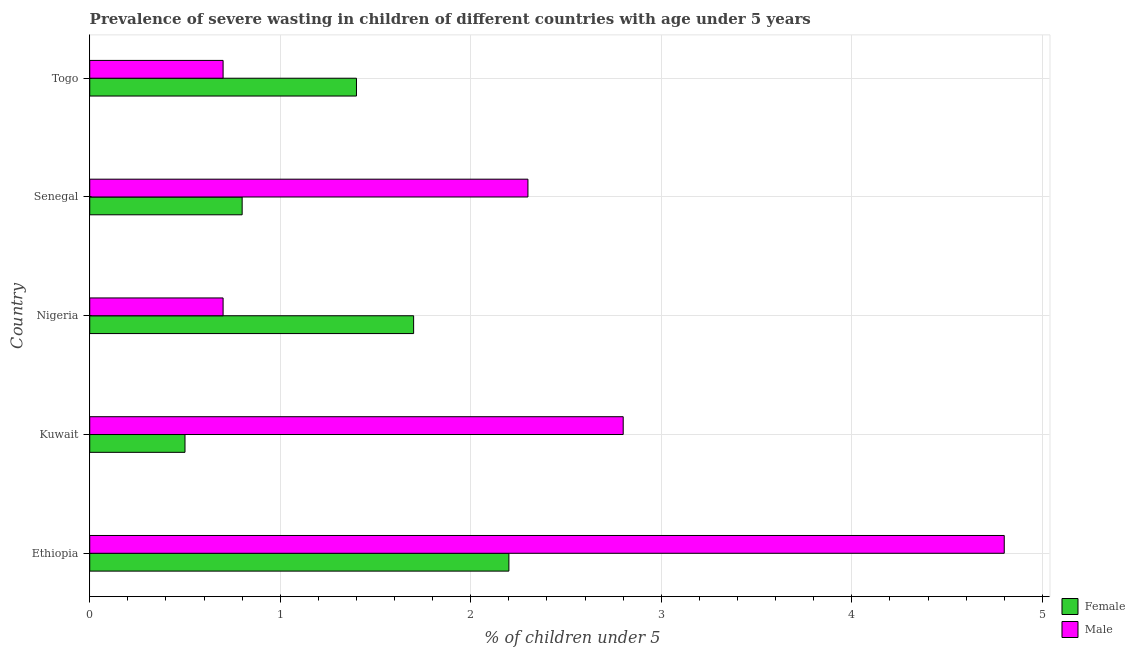How many groups of bars are there?
Provide a short and direct response. 5. Are the number of bars on each tick of the Y-axis equal?
Keep it short and to the point. Yes. How many bars are there on the 2nd tick from the bottom?
Make the answer very short. 2. What is the label of the 1st group of bars from the top?
Keep it short and to the point. Togo. In how many cases, is the number of bars for a given country not equal to the number of legend labels?
Your response must be concise. 0. What is the percentage of undernourished male children in Ethiopia?
Make the answer very short. 4.8. Across all countries, what is the maximum percentage of undernourished female children?
Ensure brevity in your answer.  2.2. Across all countries, what is the minimum percentage of undernourished male children?
Offer a very short reply. 0.7. In which country was the percentage of undernourished female children maximum?
Make the answer very short. Ethiopia. In which country was the percentage of undernourished male children minimum?
Keep it short and to the point. Nigeria. What is the total percentage of undernourished male children in the graph?
Your response must be concise. 11.3. What is the difference between the percentage of undernourished male children in Nigeria and the percentage of undernourished female children in Senegal?
Keep it short and to the point. -0.1. What is the average percentage of undernourished female children per country?
Your answer should be very brief. 1.32. What is the difference between the percentage of undernourished male children and percentage of undernourished female children in Kuwait?
Your response must be concise. 2.3. In how many countries, is the percentage of undernourished male children greater than 1.8 %?
Your answer should be compact. 3. What is the ratio of the percentage of undernourished female children in Nigeria to that in Senegal?
Provide a short and direct response. 2.12. In how many countries, is the percentage of undernourished female children greater than the average percentage of undernourished female children taken over all countries?
Keep it short and to the point. 3. Is the sum of the percentage of undernourished male children in Nigeria and Togo greater than the maximum percentage of undernourished female children across all countries?
Your answer should be compact. No. What does the 2nd bar from the top in Togo represents?
Keep it short and to the point. Female. How many countries are there in the graph?
Make the answer very short. 5. Does the graph contain any zero values?
Give a very brief answer. No. How are the legend labels stacked?
Give a very brief answer. Vertical. What is the title of the graph?
Provide a short and direct response. Prevalence of severe wasting in children of different countries with age under 5 years. What is the label or title of the X-axis?
Your answer should be compact.  % of children under 5. What is the  % of children under 5 in Female in Ethiopia?
Keep it short and to the point. 2.2. What is the  % of children under 5 in Male in Ethiopia?
Your response must be concise. 4.8. What is the  % of children under 5 in Female in Kuwait?
Your answer should be very brief. 0.5. What is the  % of children under 5 of Male in Kuwait?
Your answer should be very brief. 2.8. What is the  % of children under 5 of Female in Nigeria?
Provide a succinct answer. 1.7. What is the  % of children under 5 in Male in Nigeria?
Keep it short and to the point. 0.7. What is the  % of children under 5 of Female in Senegal?
Make the answer very short. 0.8. What is the  % of children under 5 of Male in Senegal?
Offer a very short reply. 2.3. What is the  % of children under 5 in Female in Togo?
Ensure brevity in your answer.  1.4. What is the  % of children under 5 in Male in Togo?
Your answer should be compact. 0.7. Across all countries, what is the maximum  % of children under 5 of Female?
Offer a terse response. 2.2. Across all countries, what is the maximum  % of children under 5 in Male?
Provide a succinct answer. 4.8. Across all countries, what is the minimum  % of children under 5 in Male?
Ensure brevity in your answer.  0.7. What is the total  % of children under 5 of Female in the graph?
Provide a succinct answer. 6.6. What is the difference between the  % of children under 5 in Female in Ethiopia and that in Kuwait?
Provide a succinct answer. 1.7. What is the difference between the  % of children under 5 in Female in Ethiopia and that in Nigeria?
Ensure brevity in your answer.  0.5. What is the difference between the  % of children under 5 of Male in Ethiopia and that in Nigeria?
Provide a short and direct response. 4.1. What is the difference between the  % of children under 5 in Male in Ethiopia and that in Senegal?
Make the answer very short. 2.5. What is the difference between the  % of children under 5 of Male in Ethiopia and that in Togo?
Your answer should be compact. 4.1. What is the difference between the  % of children under 5 in Female in Kuwait and that in Nigeria?
Offer a terse response. -1.2. What is the difference between the  % of children under 5 in Female in Kuwait and that in Senegal?
Provide a succinct answer. -0.3. What is the difference between the  % of children under 5 of Male in Kuwait and that in Senegal?
Provide a succinct answer. 0.5. What is the difference between the  % of children under 5 of Female in Kuwait and that in Togo?
Offer a very short reply. -0.9. What is the difference between the  % of children under 5 in Female in Senegal and that in Togo?
Your answer should be compact. -0.6. What is the difference between the  % of children under 5 of Male in Senegal and that in Togo?
Your answer should be very brief. 1.6. What is the difference between the  % of children under 5 in Female in Ethiopia and the  % of children under 5 in Male in Kuwait?
Make the answer very short. -0.6. What is the difference between the  % of children under 5 in Female in Ethiopia and the  % of children under 5 in Male in Nigeria?
Offer a very short reply. 1.5. What is the difference between the  % of children under 5 of Female in Kuwait and the  % of children under 5 of Male in Nigeria?
Your response must be concise. -0.2. What is the difference between the  % of children under 5 in Female in Kuwait and the  % of children under 5 in Male in Senegal?
Keep it short and to the point. -1.8. What is the difference between the  % of children under 5 in Female in Kuwait and the  % of children under 5 in Male in Togo?
Your response must be concise. -0.2. What is the difference between the  % of children under 5 of Female in Nigeria and the  % of children under 5 of Male in Senegal?
Your answer should be compact. -0.6. What is the difference between the  % of children under 5 of Female in Nigeria and the  % of children under 5 of Male in Togo?
Your answer should be compact. 1. What is the difference between the  % of children under 5 of Female in Senegal and the  % of children under 5 of Male in Togo?
Your answer should be very brief. 0.1. What is the average  % of children under 5 in Female per country?
Your response must be concise. 1.32. What is the average  % of children under 5 of Male per country?
Give a very brief answer. 2.26. What is the difference between the  % of children under 5 of Female and  % of children under 5 of Male in Kuwait?
Offer a very short reply. -2.3. What is the difference between the  % of children under 5 of Female and  % of children under 5 of Male in Togo?
Offer a very short reply. 0.7. What is the ratio of the  % of children under 5 in Female in Ethiopia to that in Kuwait?
Give a very brief answer. 4.4. What is the ratio of the  % of children under 5 in Male in Ethiopia to that in Kuwait?
Offer a terse response. 1.71. What is the ratio of the  % of children under 5 of Female in Ethiopia to that in Nigeria?
Offer a very short reply. 1.29. What is the ratio of the  % of children under 5 in Male in Ethiopia to that in Nigeria?
Offer a terse response. 6.86. What is the ratio of the  % of children under 5 of Female in Ethiopia to that in Senegal?
Make the answer very short. 2.75. What is the ratio of the  % of children under 5 in Male in Ethiopia to that in Senegal?
Offer a terse response. 2.09. What is the ratio of the  % of children under 5 of Female in Ethiopia to that in Togo?
Give a very brief answer. 1.57. What is the ratio of the  % of children under 5 of Male in Ethiopia to that in Togo?
Your answer should be compact. 6.86. What is the ratio of the  % of children under 5 of Female in Kuwait to that in Nigeria?
Provide a succinct answer. 0.29. What is the ratio of the  % of children under 5 in Female in Kuwait to that in Senegal?
Provide a succinct answer. 0.62. What is the ratio of the  % of children under 5 of Male in Kuwait to that in Senegal?
Offer a terse response. 1.22. What is the ratio of the  % of children under 5 of Female in Kuwait to that in Togo?
Give a very brief answer. 0.36. What is the ratio of the  % of children under 5 in Female in Nigeria to that in Senegal?
Ensure brevity in your answer.  2.12. What is the ratio of the  % of children under 5 of Male in Nigeria to that in Senegal?
Make the answer very short. 0.3. What is the ratio of the  % of children under 5 in Female in Nigeria to that in Togo?
Offer a terse response. 1.21. What is the ratio of the  % of children under 5 of Male in Senegal to that in Togo?
Offer a terse response. 3.29. 